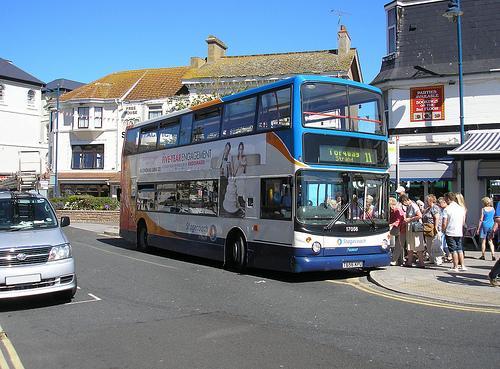Describe the appearance of some people in the image. There is a blonde woman in a blue dress, a man wearing a white shirt and blue denim shorts, and three women carrying bags. Mention some notable structures and items found in the vicinity of the street. A stone chimney on a house, ivy on a wall, a red advertisement on a white wall, a light post, and buildings with various architectural features. Express the main idea of the image in a poetic manner. In the city's bustling heartbeat, a majestic doubledecker bus patiently awaits, as souls with dreams and desires gather to continue their journey. Explain the color palette of the objects found in the image. A large blue and white bus, a gray minivan, a red advertisement, a white and blue awning, a large blue light pole, and a green bush. What are some parked vehicles and their features in the image? A doubledecker bus with an advertisement, a gray minivan with a driver's side view mirror, and a white car on the street. What is the general atmosphere and setting depicted in the image? An urban street scene with parked vehicles and people going about their daily activities, including waiting at a bus stop and walking on the sidewalk. What are the notable features of the bus in the image? The bus has two levels, a windshield with wipers, a side advertisement, a light, and a license plate. List some minor details in the image. A window of a building, a roof of a building, part of a blue sky, a black bus tire, and a man wearing white shoes. Provide a brief description of the main objects in the image. A doubledecker bus is parked on the street next to a gray minivan, while people wait to embark the bus and others walk on the sidewalk. Illustrate the contrast between natural and man-made elements in the image. While ivy embellishes a house wall and a green bush stands on the sidewalk, vehicles like buses and cars intermingle with diverse buildings and a light post, making up the urban scenery. 